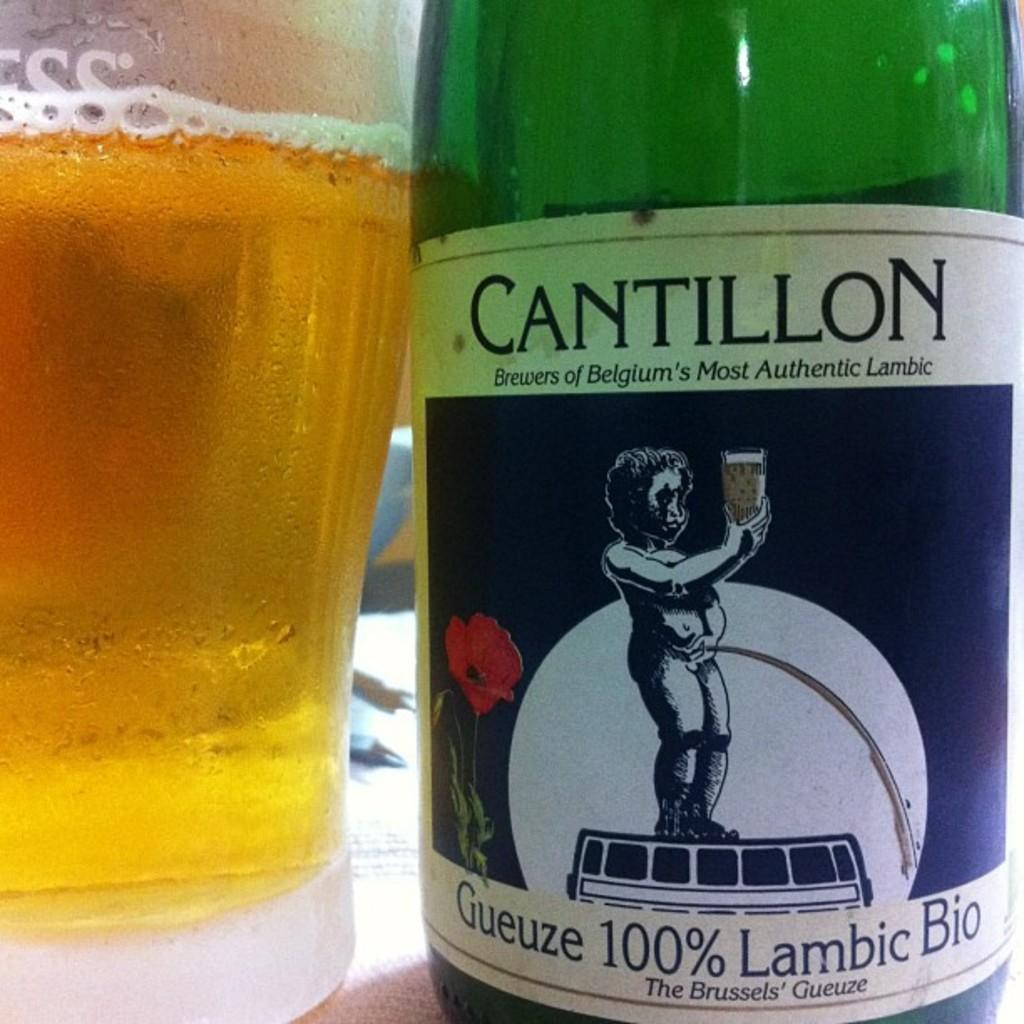<image>
Present a compact description of the photo's key features. A bottle of CAntillon Guiezue 100% lambic bio wine. 